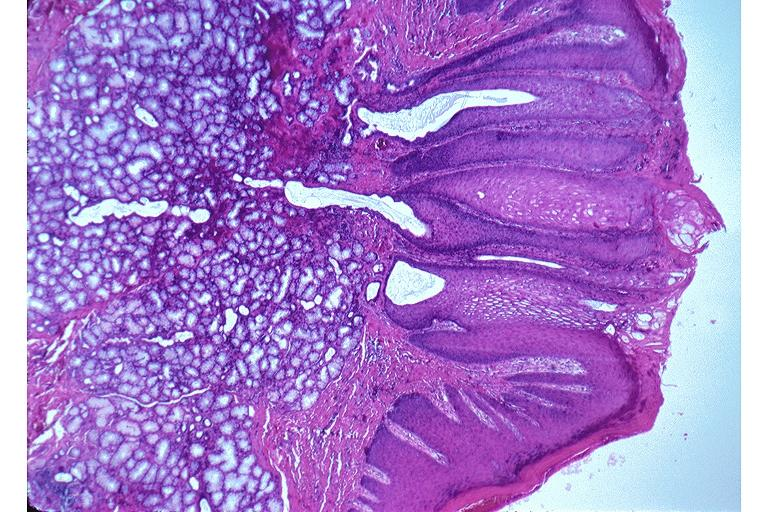what is present?
Answer the question using a single word or phrase. Oral 